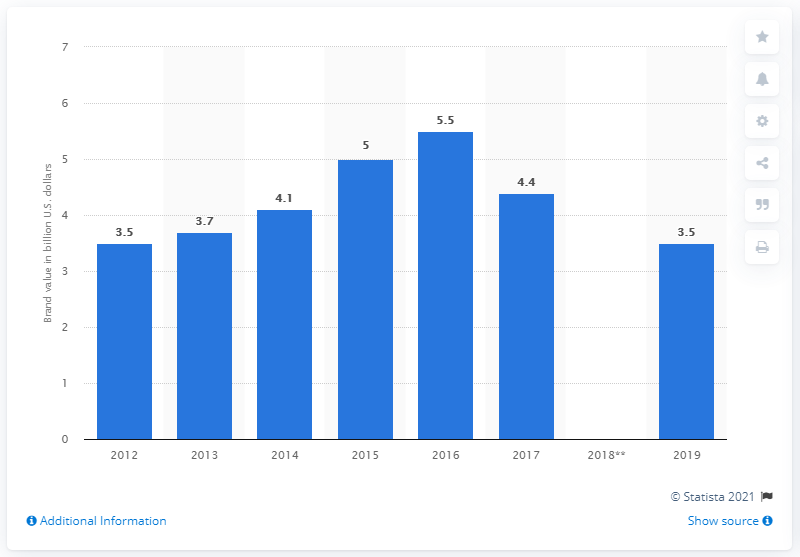Identify some key points in this picture. In 2019, the brand value of Under Armour was estimated to be approximately 3.5 billion dollars. 